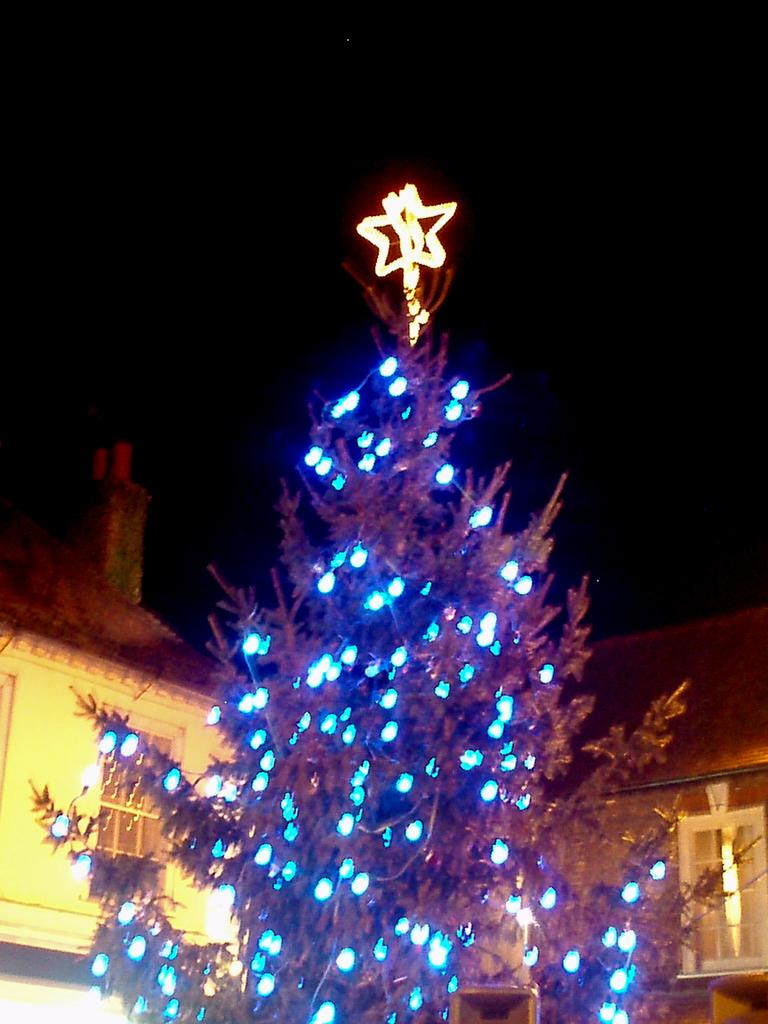What type of natural element can be seen in the image? There is a tree in the image. What artificial elements are visible in the image? There are lights and buildings visible in the image. How would you describe the overall lighting in the image? The background of the image is dark. What type of sand can be seen in the image? There is no sand present in the image. How many clocks are visible in the image? There are no clocks visible in the image. 